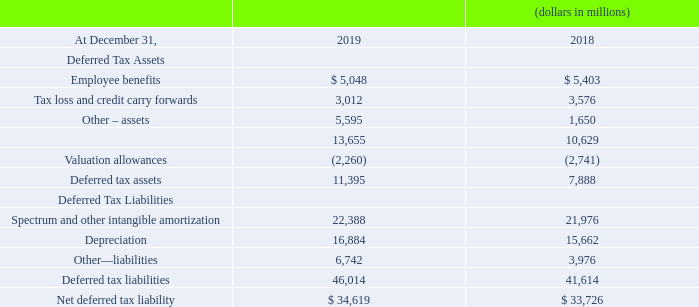Deferred taxes arise because of differences in the book and tax bases of certain assets and liabilities. Significant components of deferred tax assets and liabilities are as follows:
At December 31, 2019, undistributed earnings of our foreign subsidiaries indefinitely invested outside the U.S. amounted to approximately $3.8 billion. The majority of Verizon’s cash flow is generated from domestic operations and we are not dependent on foreign cash or earnings to meet our funding requirements, nor do we intend to repatriate these undistributed foreign earnings to fund U.S. operations.
Furthermore, a portion of these undistributed earnings represents amounts that legally must be kept in reserve in accordance with certain foreign jurisdictional requirements and are unavailable for distribution or repatriation. As a result, we have not provided U.S. deferred taxes on these undistributed earnings because we intend that they will remain indefinitely reinvested outside of the U.S. and therefore unavailable for use in funding U.S. operations. Determination of the amount of unrecognized deferred taxes related to these undistributed earnings is not practicable.
At December 31, 2019, we had net after-tax loss and credit carry forwards for income tax purposes of approximately $3.0 billion that primarily relate to state and foreign taxes. Of these net after-tax loss and credit carry forwards, approximately $2.0 billion will expire between 2020 and 2039 and approximately $1.0 billion may be carried forward indefinitely.
During 2019, the valuation allowance decreased approximately $481 million. The balance of the valuation allowance at December 31, 2019 and the 2019 activity is primarily related to state and foreign taxes.
What was the change in the employee benefit from 2018 to 2019?
Answer scale should be: million. 5,048 - 5,403
Answer: -355. What was the average tax loss and credit carry forward for 2018 and 2019?
Answer scale should be: million. (3,012 + 3,576) / 2
Answer: 3294. What was the average other assets for 2018 and 2019?
Answer scale should be: million. (5,595 + 1,650) / 2
Answer: 3622.5. What was the undistributed earnings of foreign subsidiary invested outside the US amounted to in 2019? $3.8 billion. What was the net after tax loss and credit carry forward for income tax in 2019? $3.0 billion. What was the valuation allowance decrease in 2019? $481 million. 